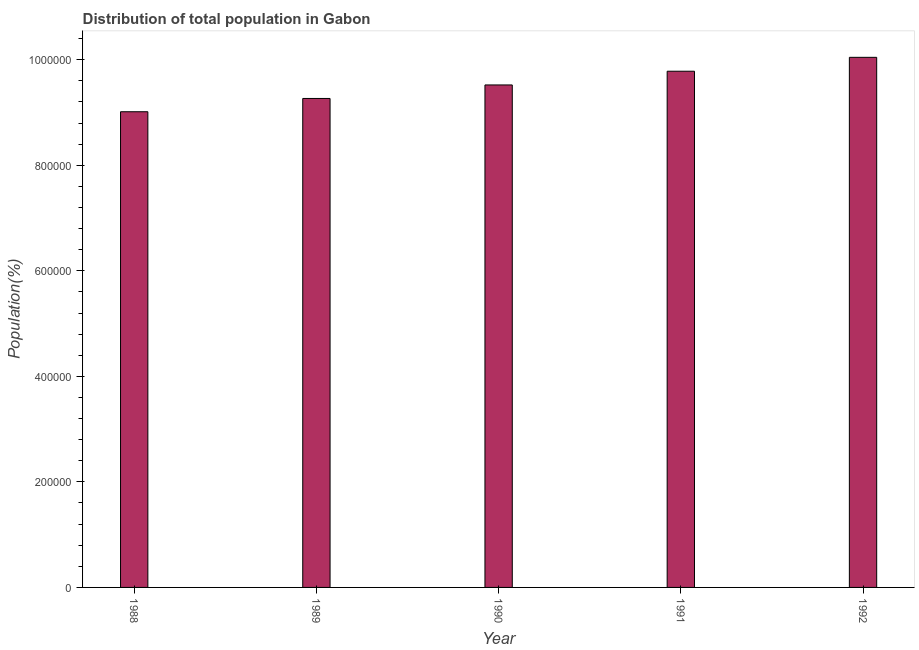Does the graph contain any zero values?
Provide a short and direct response. No. What is the title of the graph?
Offer a terse response. Distribution of total population in Gabon . What is the label or title of the Y-axis?
Provide a short and direct response. Population(%). What is the population in 1991?
Your answer should be compact. 9.78e+05. Across all years, what is the maximum population?
Provide a short and direct response. 1.00e+06. Across all years, what is the minimum population?
Your answer should be very brief. 9.01e+05. In which year was the population minimum?
Your answer should be very brief. 1988. What is the sum of the population?
Give a very brief answer. 4.76e+06. What is the difference between the population in 1988 and 1989?
Make the answer very short. -2.52e+04. What is the average population per year?
Provide a short and direct response. 9.53e+05. What is the median population?
Ensure brevity in your answer.  9.52e+05. In how many years, is the population greater than 880000 %?
Provide a succinct answer. 5. Do a majority of the years between 1992 and 1989 (inclusive) have population greater than 520000 %?
Make the answer very short. Yes. What is the ratio of the population in 1988 to that in 1992?
Your answer should be compact. 0.9. Is the population in 1988 less than that in 1989?
Make the answer very short. Yes. Is the difference between the population in 1989 and 1991 greater than the difference between any two years?
Your response must be concise. No. What is the difference between the highest and the second highest population?
Your response must be concise. 2.63e+04. What is the difference between the highest and the lowest population?
Give a very brief answer. 1.03e+05. Are all the bars in the graph horizontal?
Make the answer very short. No. What is the difference between two consecutive major ticks on the Y-axis?
Provide a short and direct response. 2.00e+05. Are the values on the major ticks of Y-axis written in scientific E-notation?
Make the answer very short. No. What is the Population(%) in 1988?
Your answer should be compact. 9.01e+05. What is the Population(%) of 1989?
Provide a succinct answer. 9.27e+05. What is the Population(%) of 1990?
Give a very brief answer. 9.52e+05. What is the Population(%) of 1991?
Make the answer very short. 9.78e+05. What is the Population(%) of 1992?
Provide a short and direct response. 1.00e+06. What is the difference between the Population(%) in 1988 and 1989?
Offer a very short reply. -2.52e+04. What is the difference between the Population(%) in 1988 and 1990?
Keep it short and to the point. -5.08e+04. What is the difference between the Population(%) in 1988 and 1991?
Give a very brief answer. -7.68e+04. What is the difference between the Population(%) in 1988 and 1992?
Offer a very short reply. -1.03e+05. What is the difference between the Population(%) in 1989 and 1990?
Make the answer very short. -2.56e+04. What is the difference between the Population(%) in 1989 and 1991?
Your response must be concise. -5.16e+04. What is the difference between the Population(%) in 1989 and 1992?
Offer a terse response. -7.80e+04. What is the difference between the Population(%) in 1990 and 1991?
Your answer should be compact. -2.60e+04. What is the difference between the Population(%) in 1990 and 1992?
Provide a short and direct response. -5.23e+04. What is the difference between the Population(%) in 1991 and 1992?
Make the answer very short. -2.63e+04. What is the ratio of the Population(%) in 1988 to that in 1989?
Your response must be concise. 0.97. What is the ratio of the Population(%) in 1988 to that in 1990?
Your response must be concise. 0.95. What is the ratio of the Population(%) in 1988 to that in 1991?
Your answer should be very brief. 0.92. What is the ratio of the Population(%) in 1988 to that in 1992?
Your answer should be compact. 0.9. What is the ratio of the Population(%) in 1989 to that in 1991?
Provide a short and direct response. 0.95. What is the ratio of the Population(%) in 1989 to that in 1992?
Offer a terse response. 0.92. What is the ratio of the Population(%) in 1990 to that in 1992?
Offer a terse response. 0.95. What is the ratio of the Population(%) in 1991 to that in 1992?
Your answer should be compact. 0.97. 